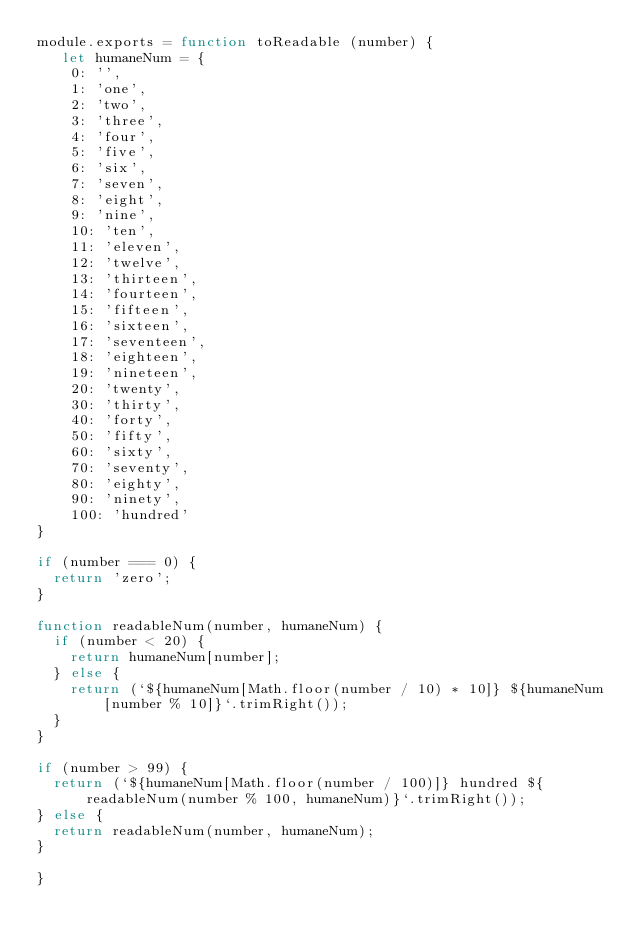<code> <loc_0><loc_0><loc_500><loc_500><_JavaScript_>module.exports = function toReadable (number) {
   let humaneNum = {
    0: '',
    1: 'one',
    2: 'two',
    3: 'three',
    4: 'four',
    5: 'five',
    6: 'six',
    7: 'seven',
    8: 'eight',
    9: 'nine',
    10: 'ten',
    11: 'eleven',
    12: 'twelve',
    13: 'thirteen',
    14: 'fourteen',
    15: 'fifteen',
    16: 'sixteen',
    17: 'seventeen',
    18: 'eighteen',
    19: 'nineteen',
    20: 'twenty',
    30: 'thirty',
    40: 'forty',
    50: 'fifty',
    60: 'sixty',
    70: 'seventy',
    80: 'eighty',
    90: 'ninety',
    100: 'hundred'
}

if (number === 0) {
  return 'zero';
}

function readableNum(number, humaneNum) {
  if (number < 20) {
    return humaneNum[number];
  } else {
    return (`${humaneNum[Math.floor(number / 10) * 10]} ${humaneNum[number % 10]}`.trimRight());
  }
}

if (number > 99) {
  return (`${humaneNum[Math.floor(number / 100)]} hundred ${readableNum(number % 100, humaneNum)}`.trimRight());
} else {
  return readableNum(number, humaneNum);
}

}</code> 